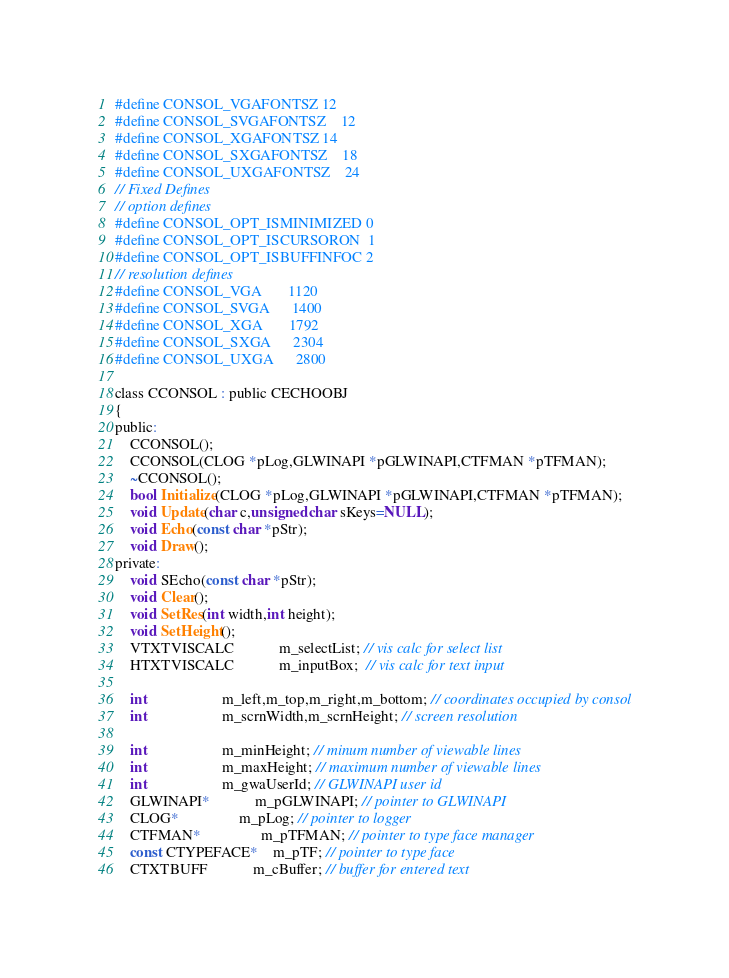Convert code to text. <code><loc_0><loc_0><loc_500><loc_500><_C_>#define CONSOL_VGAFONTSZ	12
#define CONSOL_SVGAFONTSZ	12
#define CONSOL_XGAFONTSZ	14
#define CONSOL_SXGAFONTSZ	18
#define CONSOL_UXGAFONTSZ	24
// Fixed Defines
// option defines
#define CONSOL_OPT_ISMINIMIZED 0
#define CONSOL_OPT_ISCURSORON  1
#define CONSOL_OPT_ISBUFFINFOC 2
// resolution defines
#define CONSOL_VGA		1120
#define CONSOL_SVGA		1400
#define CONSOL_XGA		1792
#define CONSOL_SXGA		2304
#define CONSOL_UXGA		2800

class CCONSOL : public CECHOOBJ
{
public:
	CCONSOL();
	CCONSOL(CLOG *pLog,GLWINAPI *pGLWINAPI,CTFMAN *pTFMAN);
	~CCONSOL();
	bool Initialize(CLOG *pLog,GLWINAPI *pGLWINAPI,CTFMAN *pTFMAN);
	void Update(char c,unsigned char sKeys=NULL);
	void Echo(const char *pStr);
	void Draw();
private:
	void SEcho(const char *pStr);
	void Clear();
	void SetRes(int width,int height);
	void SetHeight();
	VTXTVISCALC			m_selectList; // vis calc for select list
	HTXTVISCALC			m_inputBox;  // vis calc for text input 

	int					m_left,m_top,m_right,m_bottom; // coordinates occupied by consol
	int					m_scrnWidth,m_scrnHeight; // screen resolution

	int					m_minHeight; // minum number of viewable lines
	int					m_maxHeight; // maximum number of viewable lines
	int					m_gwaUserId; // GLWINAPI user id
	GLWINAPI*			m_pGLWINAPI; // pointer to GLWINAPI
	CLOG*				m_pLog; // pointer to logger
	CTFMAN*				m_pTFMAN; // pointer to type face manager
	const CTYPEFACE*	m_pTF; // pointer to type face
	CTXTBUFF			m_cBuffer; // buffer for entered text</code> 